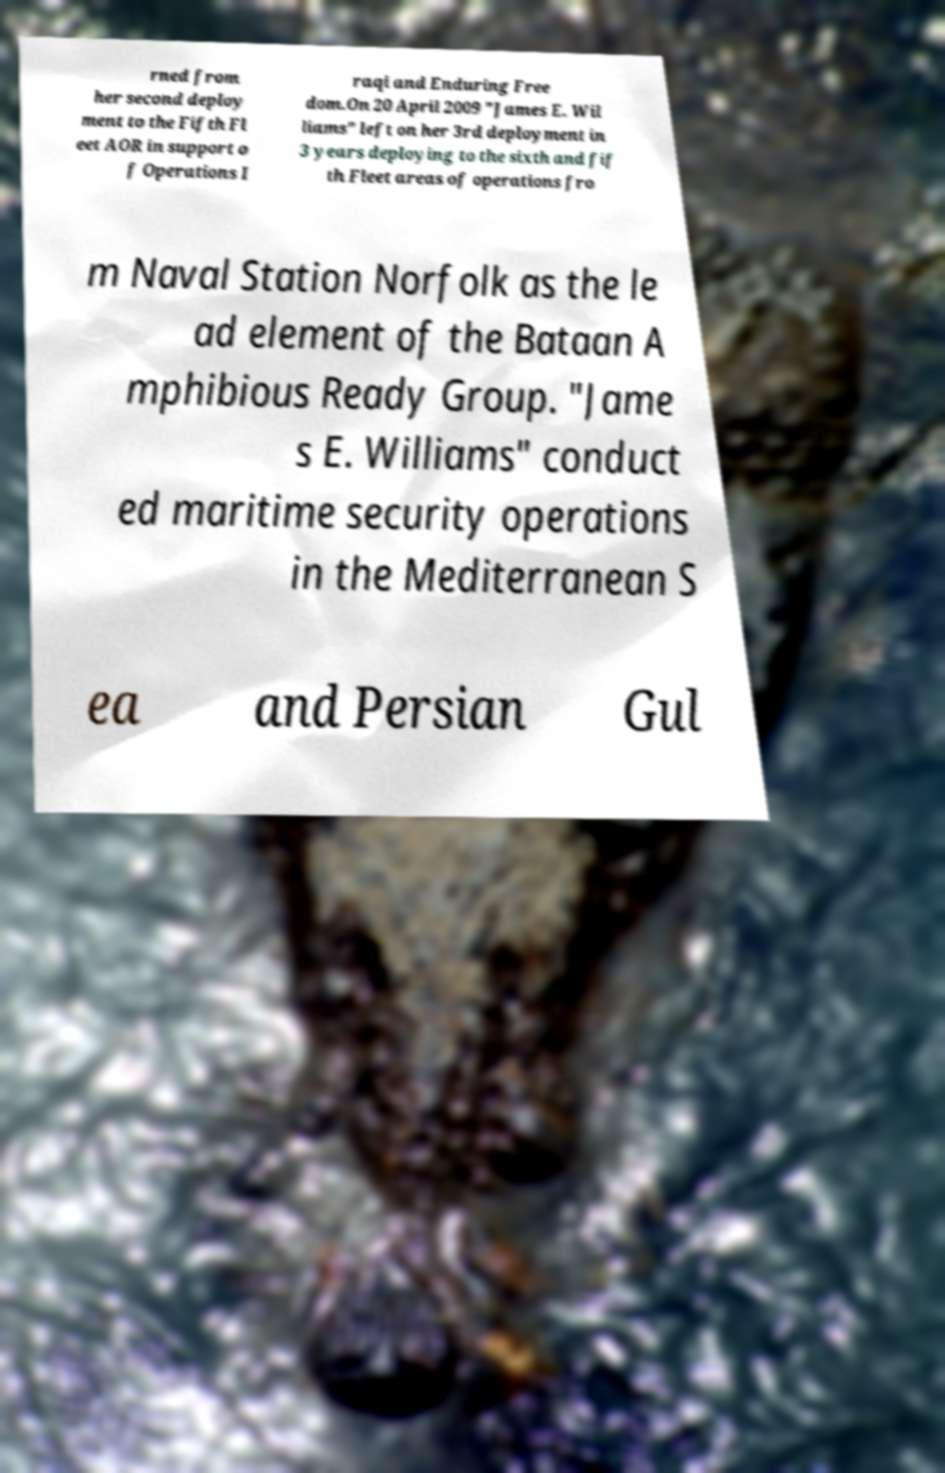Can you read and provide the text displayed in the image?This photo seems to have some interesting text. Can you extract and type it out for me? rned from her second deploy ment to the Fifth Fl eet AOR in support o f Operations I raqi and Enduring Free dom.On 20 April 2009 "James E. Wil liams" left on her 3rd deployment in 3 years deploying to the sixth and fif th Fleet areas of operations fro m Naval Station Norfolk as the le ad element of the Bataan A mphibious Ready Group. "Jame s E. Williams" conduct ed maritime security operations in the Mediterranean S ea and Persian Gul 